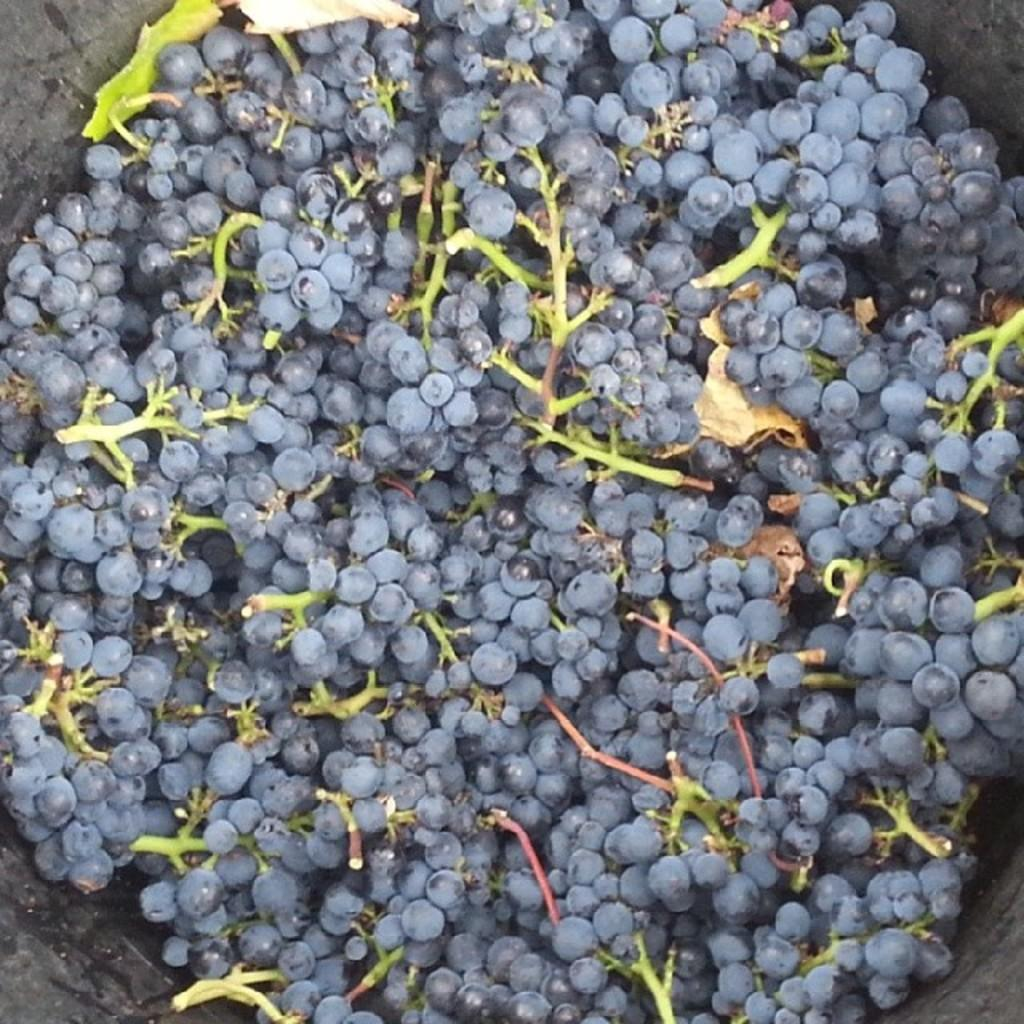What type of fruit is visible in the image? There are bunches of grapes in the image. In what kind of container or object are the grapes placed? The grapes are in an object. What type of work is being done in the image? There is no indication of work being done in the image; it primarily features bunches of grapes in an object. 